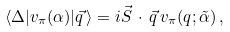Convert formula to latex. <formula><loc_0><loc_0><loc_500><loc_500>\langle \Delta | v _ { \pi } ( \alpha ) | \vec { q } \, \rangle = i \vec { S } \, \cdot \, \vec { q } \, v _ { \pi } ( q ; \tilde { \alpha } ) \, ,</formula> 